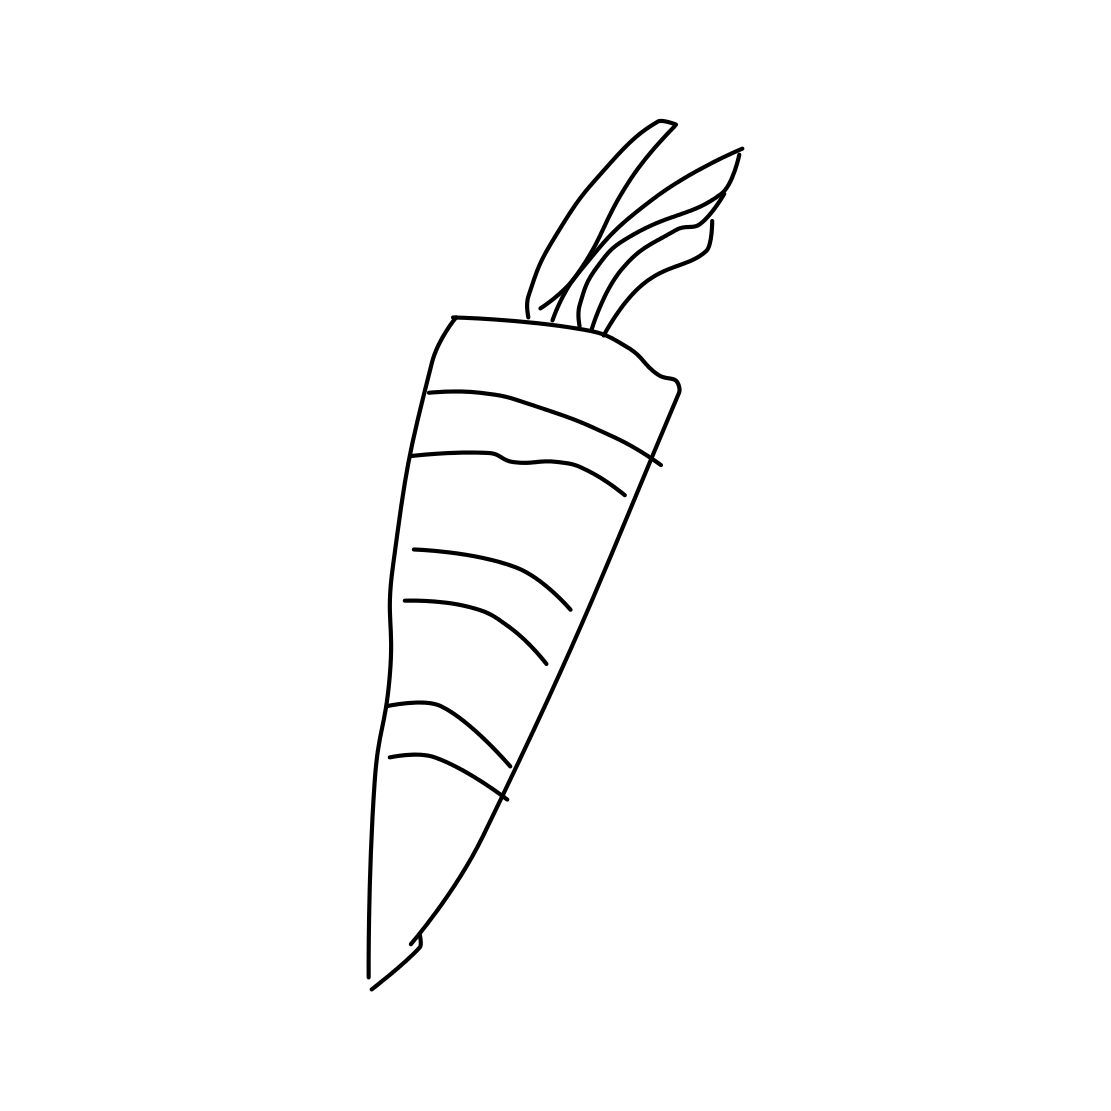Could you explain the significance of the carrot’s design in terms of artistic elements? Certainly! The artistic presentation of the carrot in the image utilizes a minimalist and line-based drawing style that focuses on clarity and simplicity. This technique highlights the fundamental shapes and contours of the carrot without unnecessary detail, allowing for immediate recognition and emphasizing the universal visual nature of this vegetable. How might this style contribute to the perception of the carrot? The minimalist style tends to convey a sense of modernity and elegance. It strips away complexities, presenting the carrot in a straightforward, clean appearance that can be visually pleasing and easily integrated into various design contexts, such as educational materials or modern kitchen art. 